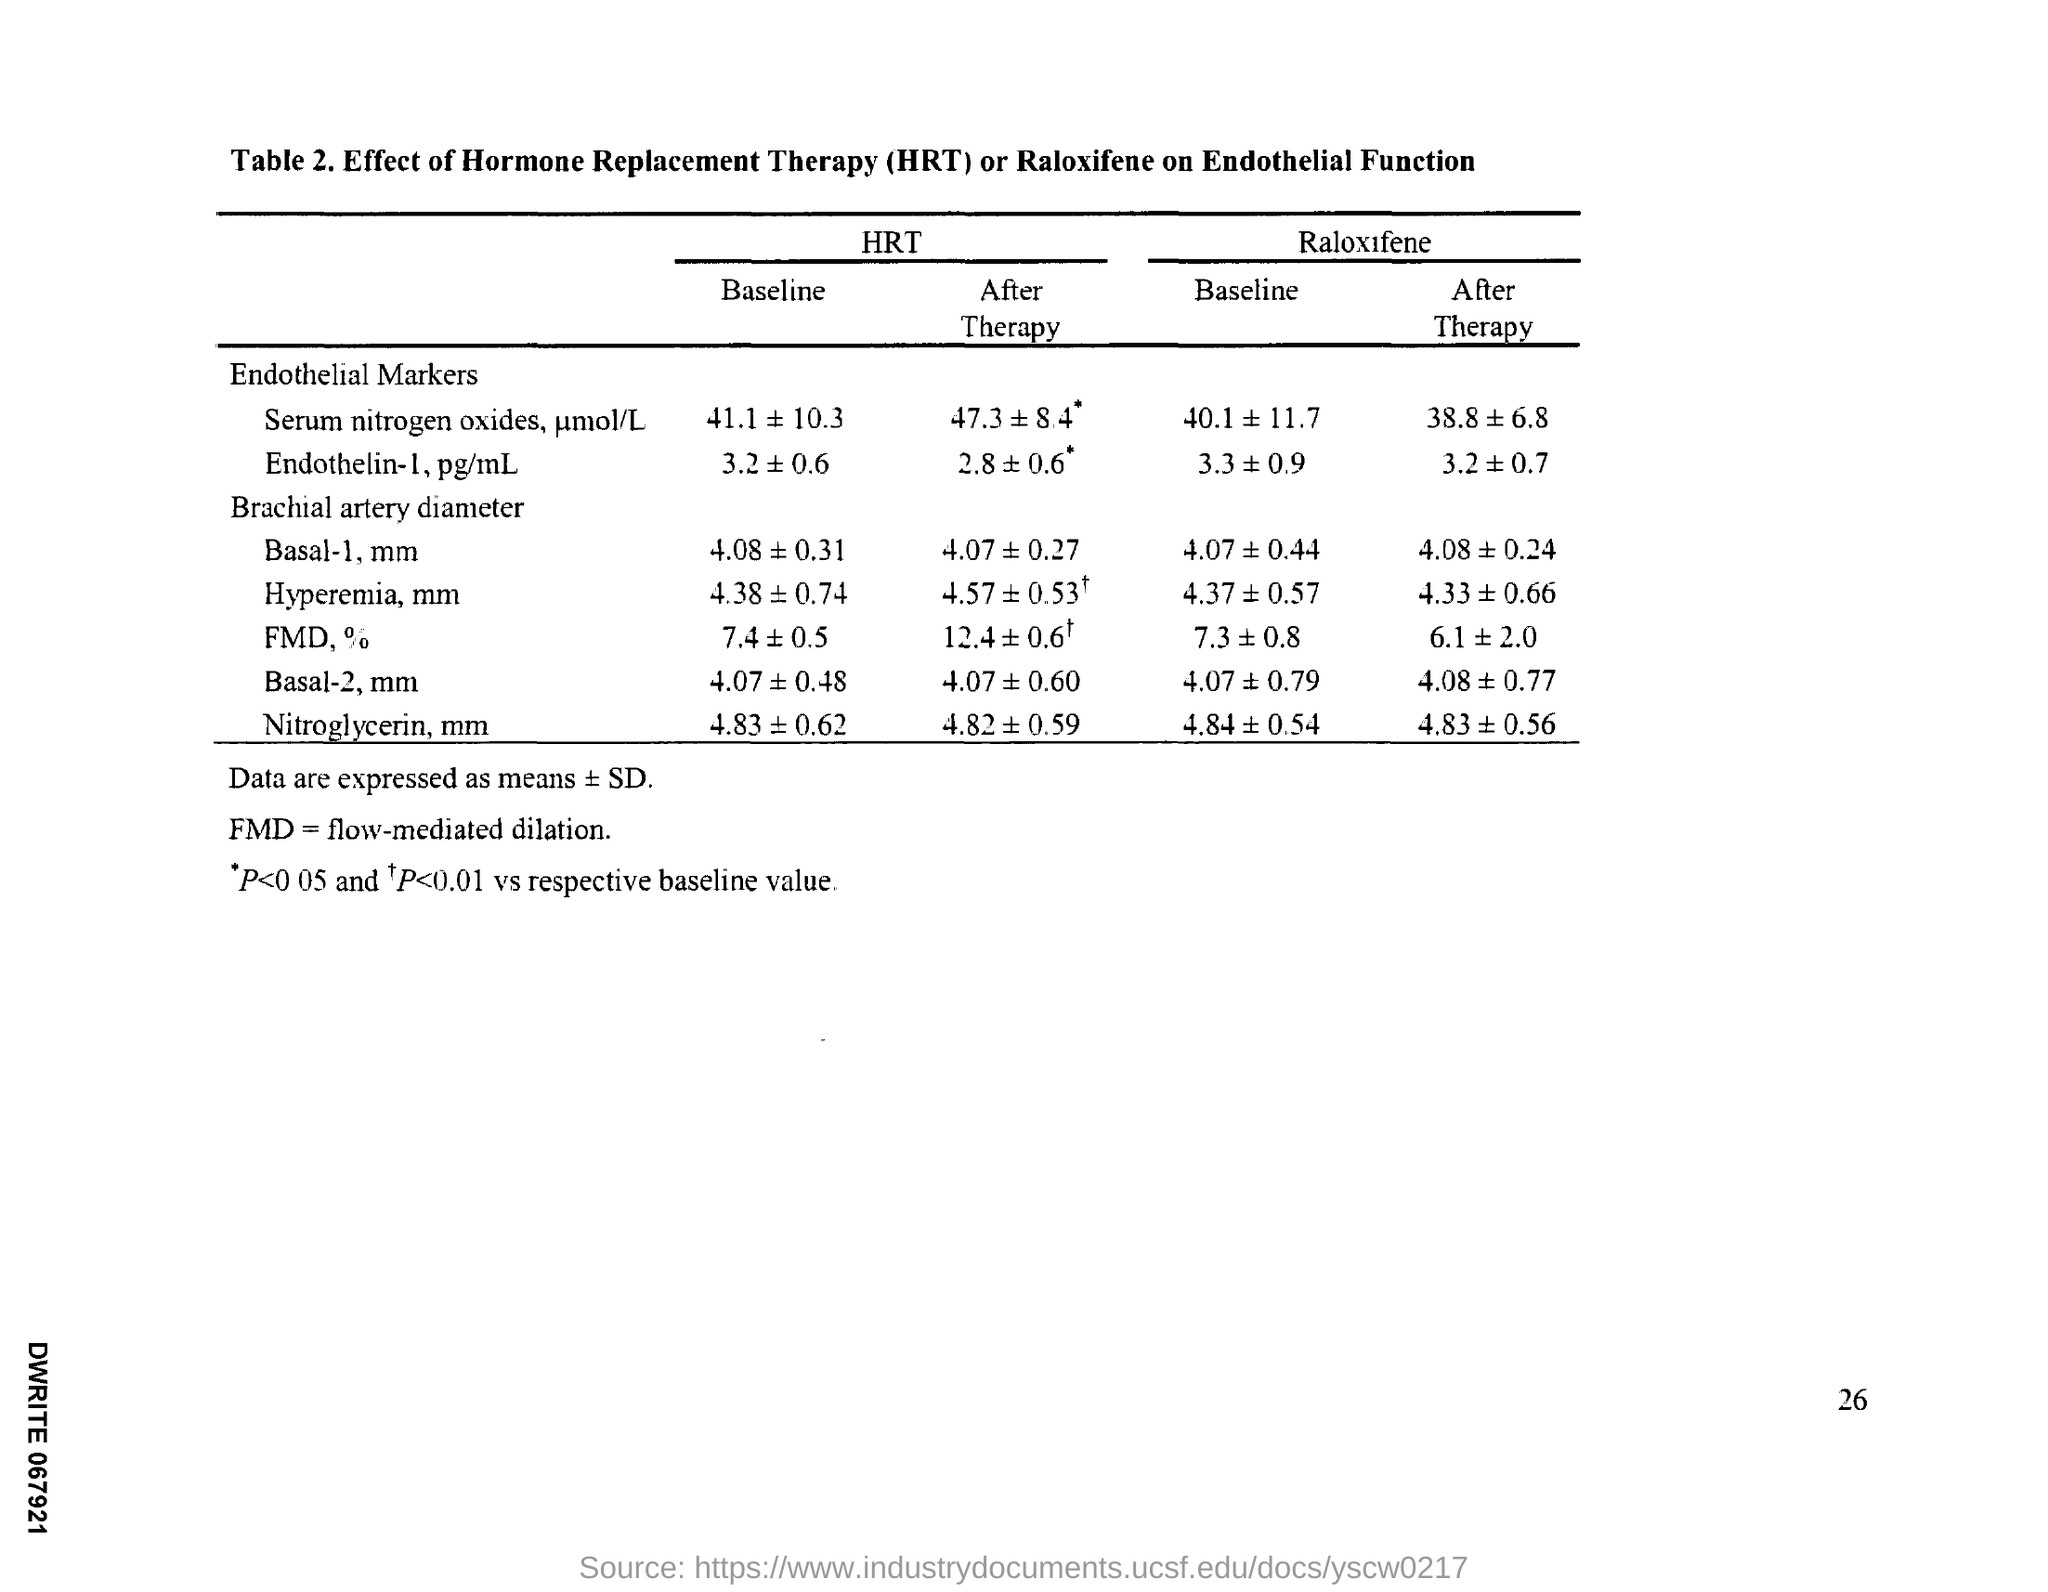What is the Page Number?
Provide a short and direct response. 26. 